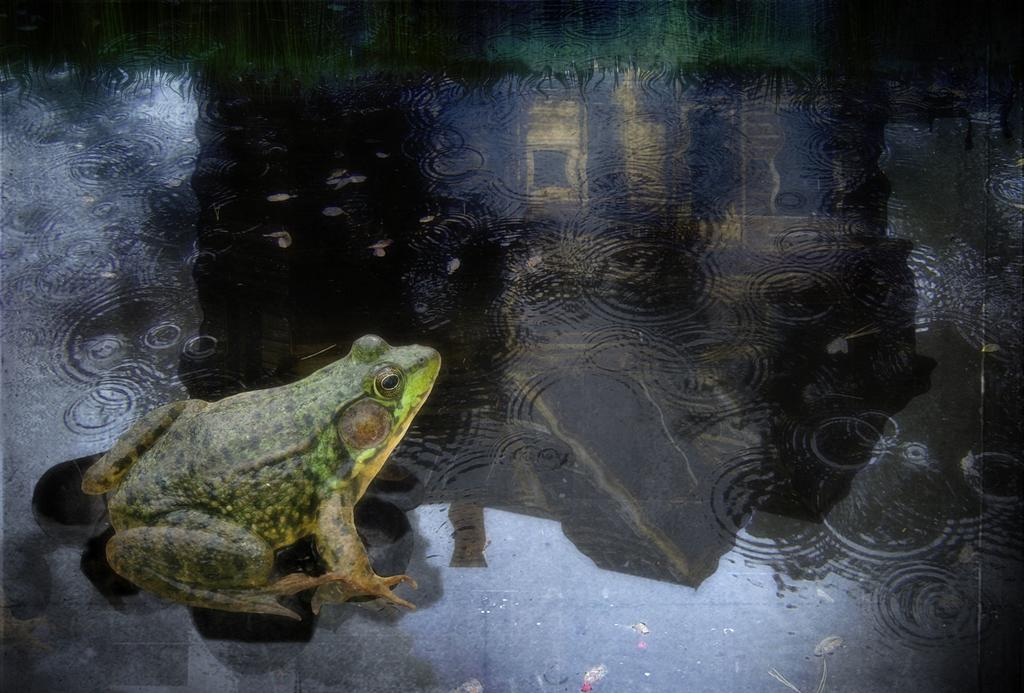What is the main subject of the image? The main subject of the image is an animation picture of a frog. Where is the frog located in the image? The frog is depicted on the water. How many bananas are floating next to the frog in the image? There are no bananas present in the image; it only features an animation picture of a frog on the water. 